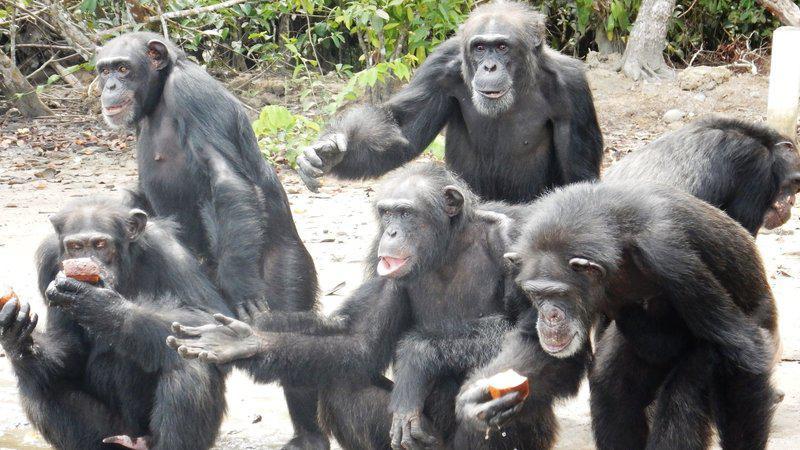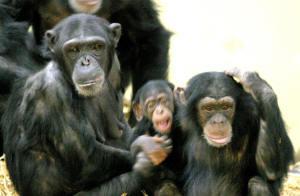The first image is the image on the left, the second image is the image on the right. For the images displayed, is the sentence "An image features one trio of interacting chimps facing forward." factually correct? Answer yes or no. Yes. The first image is the image on the left, the second image is the image on the right. Evaluate the accuracy of this statement regarding the images: "A baby ape is touching an adult ape's hand". Is it true? Answer yes or no. Yes. 